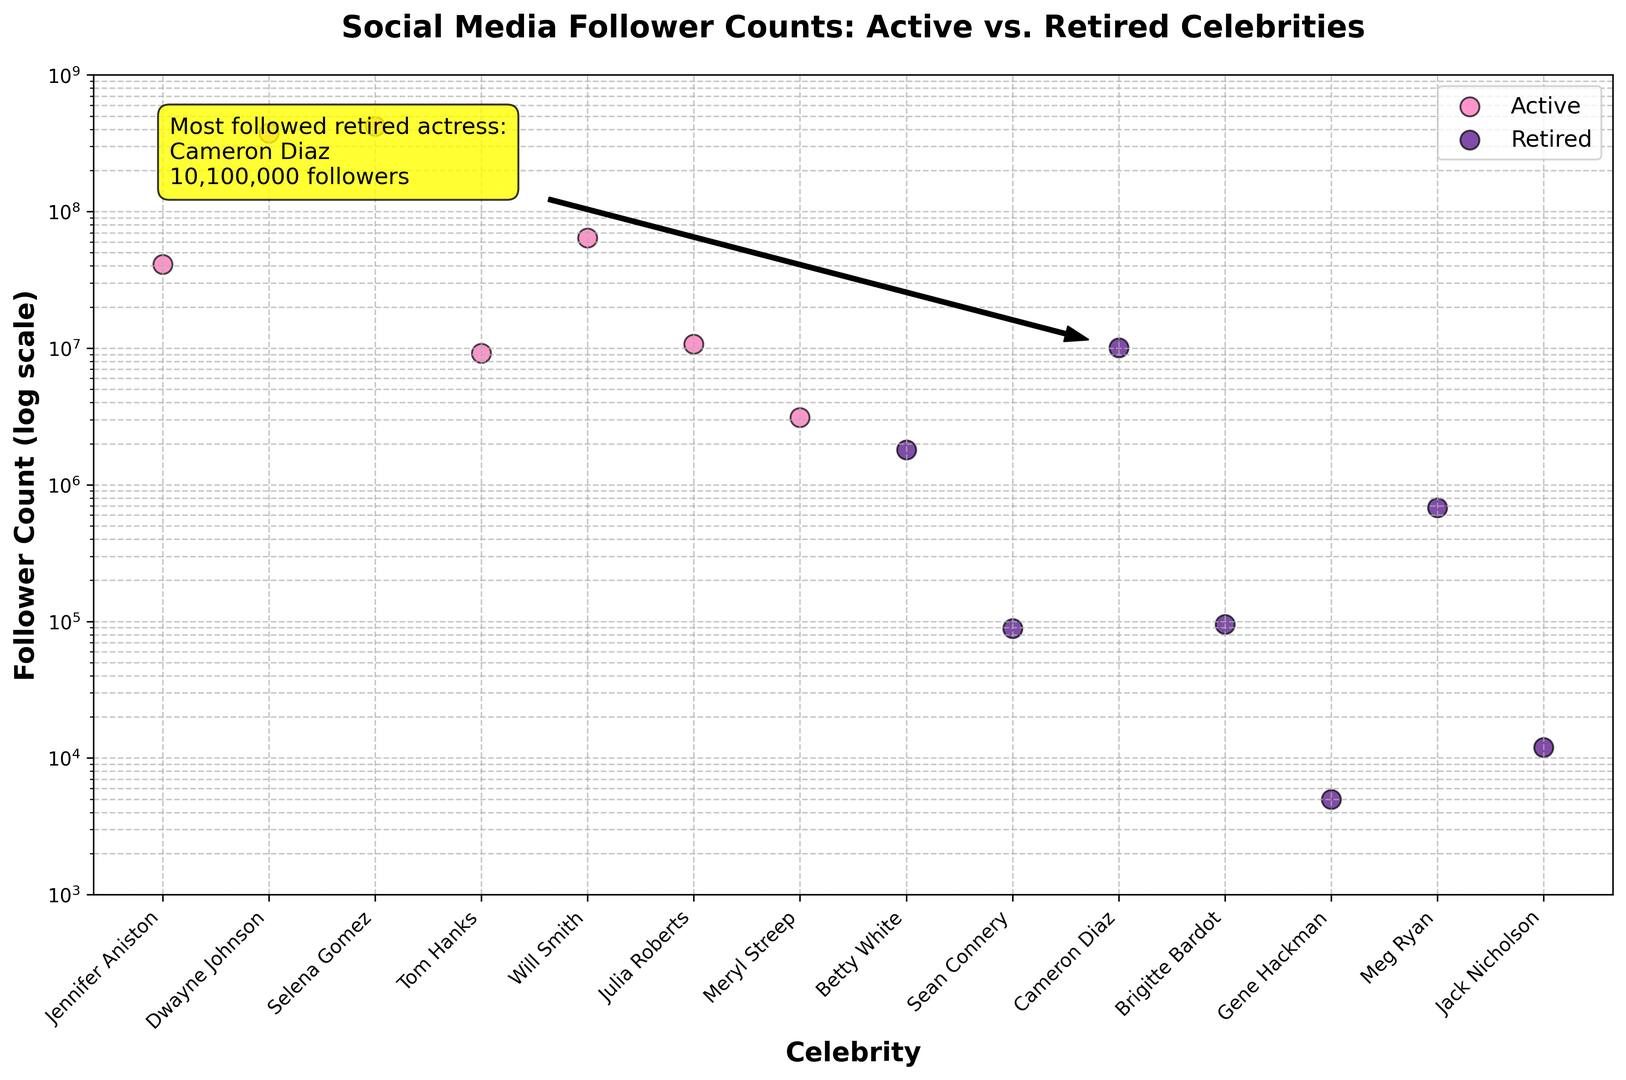Who is the most followed retired actress? The annotation on the figure highlights the most followed retired actress as Cameron Diaz with a specific mention of 10,100,000 followers.
Answer: Cameron Diaz How many more followers does Will Smith have compared to Tom Hanks? Look at the figure for the follower count of both Will Smith and Tom Hanks. Will Smith has 64,300,000 followers, while Tom Hanks has 9,200,000 followers. The difference is 64,300,000 - 9,200,000.
Answer: 55,100,000 What is the combined follower count of all retired celebrities? Sum the follower counts of all the retired celebrities: Betty White (1,800,000), Sean Connery (89,000), Cameron Diaz (10,100,000), Brigitte Bardot (95,000), Gene Hackman (5,000), Meg Ryan (680,000), Jack Nicholson (12,000). The total is 1,800,000 + 89,000 + 10,100,000 + 95,000 + 5,000 + 680,000 + 12,000.
Answer: 12,781,000 Which active performer has the highest follower count? Look at the scatter points for active celebrities and identify the one with the highest position on the y-axis. Selena Gomez is highlighted with 420,000,000 followers.
Answer: Selena Gomez Who has fewer followers, Betty White or Meg Ryan? Compare the follower counts of Betty White and Meg Ryan. Betty White has 1,800,000 followers, while Meg Ryan has 680,000 followers. Meg Ryan has fewer.
Answer: Meg Ryan Are there any retired celebrities with fewer than 10,000 followers? Look at the scatter points for retired celebrities and check if any are positioned below 10,000 followers on the y-axis. Gene Hackman with 5,000 followers meets this criterion.
Answer: Yes, Gene Hackman What is the follower count range for active celebrities in the plot? Identify the highest and lowest follower counts among active celebrities. Selena Gomez has the highest with 420,000,000 followers, and Meryl Streep has the lowest with 3,100,000 followers.
Answer: 3,100,000 to 420,000,000 Which celebrity, active or retired, has a follower count closest to 10,000,000? Compare all follower counts in the plot and find the one closest to 10,000,000. Cameron Diaz, a retired celebrity, has 10,100,000 followers, which is closest.
Answer: Cameron Diaz 